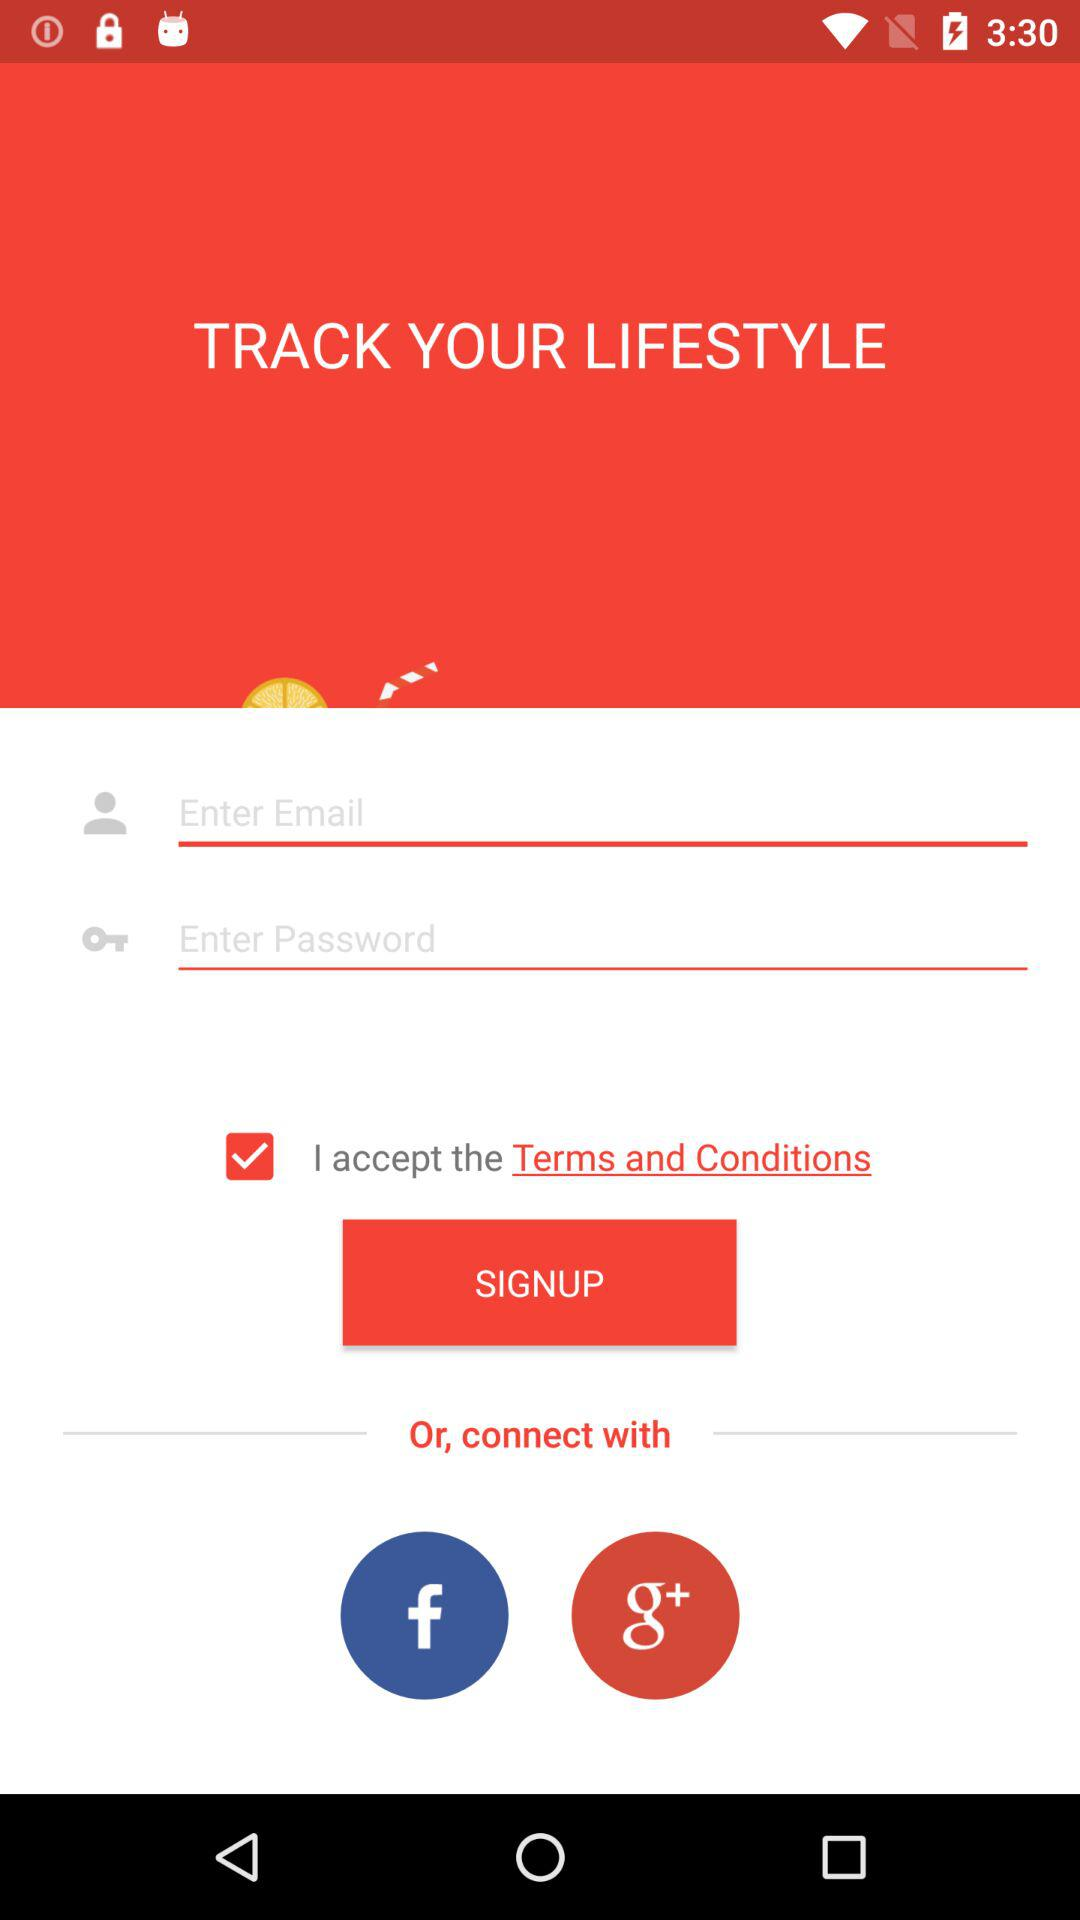What is the status of the option that includes acceptance of the “Terms and Conditions”? The status is "on". 